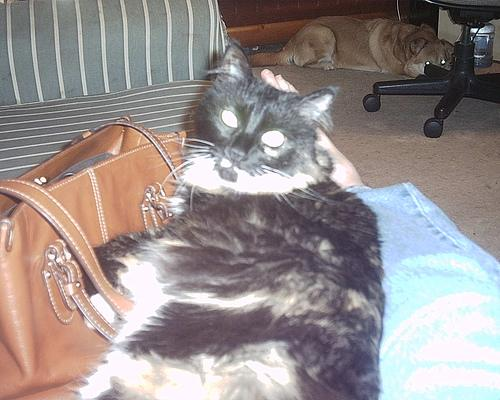Why are the animals eyes white? Please explain your reasoning. light reflection. They are blurred out. 